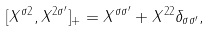Convert formula to latex. <formula><loc_0><loc_0><loc_500><loc_500>[ X ^ { \sigma 2 } , X ^ { 2 \sigma ^ { \prime } } ] _ { + } = X ^ { \sigma \sigma ^ { \prime } } + X ^ { 2 2 } \delta _ { \sigma \sigma ^ { \prime } } ,</formula> 